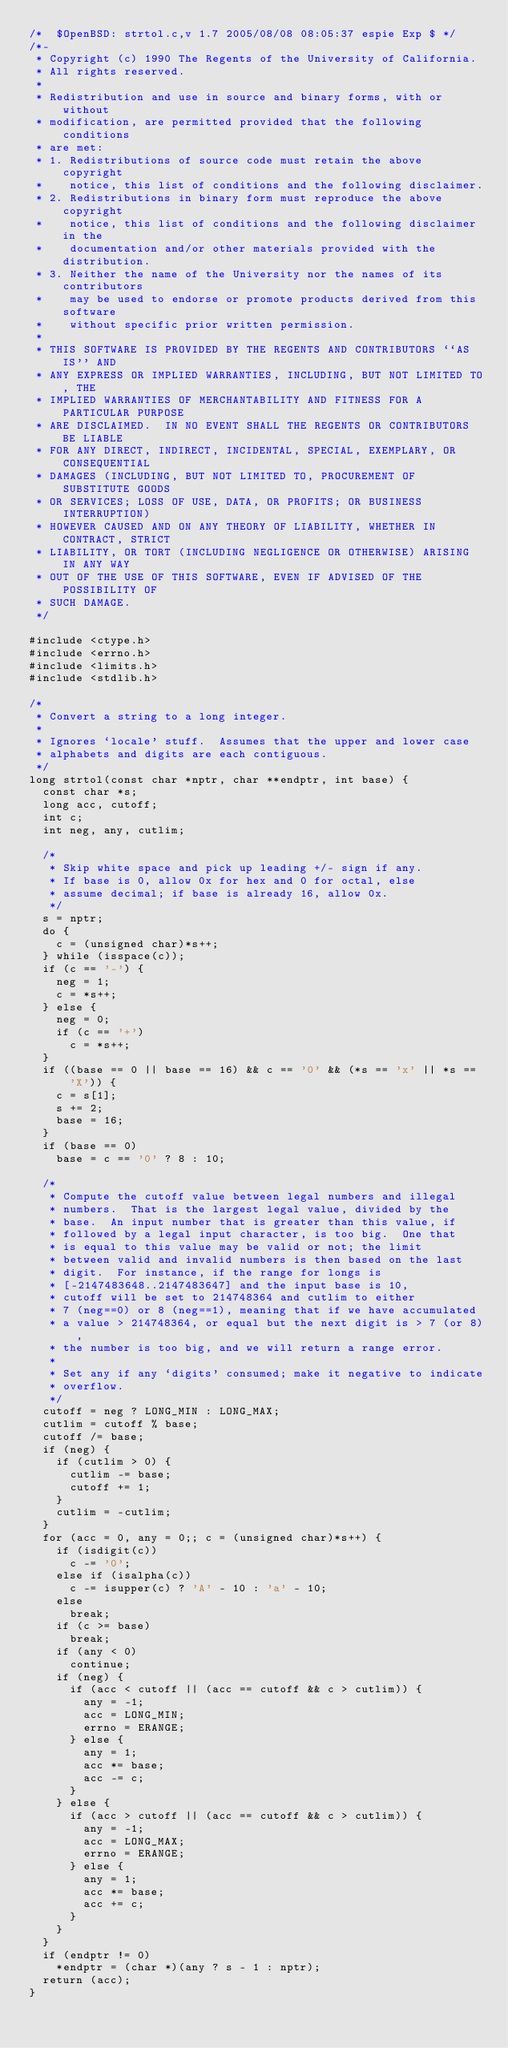Convert code to text. <code><loc_0><loc_0><loc_500><loc_500><_C_>/*  $OpenBSD: strtol.c,v 1.7 2005/08/08 08:05:37 espie Exp $ */
/*-
 * Copyright (c) 1990 The Regents of the University of California.
 * All rights reserved.
 *
 * Redistribution and use in source and binary forms, with or without
 * modification, are permitted provided that the following conditions
 * are met:
 * 1. Redistributions of source code must retain the above copyright
 *    notice, this list of conditions and the following disclaimer.
 * 2. Redistributions in binary form must reproduce the above copyright
 *    notice, this list of conditions and the following disclaimer in the
 *    documentation and/or other materials provided with the distribution.
 * 3. Neither the name of the University nor the names of its contributors
 *    may be used to endorse or promote products derived from this software
 *    without specific prior written permission.
 *
 * THIS SOFTWARE IS PROVIDED BY THE REGENTS AND CONTRIBUTORS ``AS IS'' AND
 * ANY EXPRESS OR IMPLIED WARRANTIES, INCLUDING, BUT NOT LIMITED TO, THE
 * IMPLIED WARRANTIES OF MERCHANTABILITY AND FITNESS FOR A PARTICULAR PURPOSE
 * ARE DISCLAIMED.  IN NO EVENT SHALL THE REGENTS OR CONTRIBUTORS BE LIABLE
 * FOR ANY DIRECT, INDIRECT, INCIDENTAL, SPECIAL, EXEMPLARY, OR CONSEQUENTIAL
 * DAMAGES (INCLUDING, BUT NOT LIMITED TO, PROCUREMENT OF SUBSTITUTE GOODS
 * OR SERVICES; LOSS OF USE, DATA, OR PROFITS; OR BUSINESS INTERRUPTION)
 * HOWEVER CAUSED AND ON ANY THEORY OF LIABILITY, WHETHER IN CONTRACT, STRICT
 * LIABILITY, OR TORT (INCLUDING NEGLIGENCE OR OTHERWISE) ARISING IN ANY WAY
 * OUT OF THE USE OF THIS SOFTWARE, EVEN IF ADVISED OF THE POSSIBILITY OF
 * SUCH DAMAGE.
 */

#include <ctype.h>
#include <errno.h>
#include <limits.h>
#include <stdlib.h>

/*
 * Convert a string to a long integer.
 *
 * Ignores `locale' stuff.  Assumes that the upper and lower case
 * alphabets and digits are each contiguous.
 */
long strtol(const char *nptr, char **endptr, int base) {
  const char *s;
  long acc, cutoff;
  int c;
  int neg, any, cutlim;

  /*
   * Skip white space and pick up leading +/- sign if any.
   * If base is 0, allow 0x for hex and 0 for octal, else
   * assume decimal; if base is already 16, allow 0x.
   */
  s = nptr;
  do {
    c = (unsigned char)*s++;
  } while (isspace(c));
  if (c == '-') {
    neg = 1;
    c = *s++;
  } else {
    neg = 0;
    if (c == '+')
      c = *s++;
  }
  if ((base == 0 || base == 16) && c == '0' && (*s == 'x' || *s == 'X')) {
    c = s[1];
    s += 2;
    base = 16;
  }
  if (base == 0)
    base = c == '0' ? 8 : 10;

  /*
   * Compute the cutoff value between legal numbers and illegal
   * numbers.  That is the largest legal value, divided by the
   * base.  An input number that is greater than this value, if
   * followed by a legal input character, is too big.  One that
   * is equal to this value may be valid or not; the limit
   * between valid and invalid numbers is then based on the last
   * digit.  For instance, if the range for longs is
   * [-2147483648..2147483647] and the input base is 10,
   * cutoff will be set to 214748364 and cutlim to either
   * 7 (neg==0) or 8 (neg==1), meaning that if we have accumulated
   * a value > 214748364, or equal but the next digit is > 7 (or 8),
   * the number is too big, and we will return a range error.
   *
   * Set any if any `digits' consumed; make it negative to indicate
   * overflow.
   */
  cutoff = neg ? LONG_MIN : LONG_MAX;
  cutlim = cutoff % base;
  cutoff /= base;
  if (neg) {
    if (cutlim > 0) {
      cutlim -= base;
      cutoff += 1;
    }
    cutlim = -cutlim;
  }
  for (acc = 0, any = 0;; c = (unsigned char)*s++) {
    if (isdigit(c))
      c -= '0';
    else if (isalpha(c))
      c -= isupper(c) ? 'A' - 10 : 'a' - 10;
    else
      break;
    if (c >= base)
      break;
    if (any < 0)
      continue;
    if (neg) {
      if (acc < cutoff || (acc == cutoff && c > cutlim)) {
        any = -1;
        acc = LONG_MIN;
        errno = ERANGE;
      } else {
        any = 1;
        acc *= base;
        acc -= c;
      }
    } else {
      if (acc > cutoff || (acc == cutoff && c > cutlim)) {
        any = -1;
        acc = LONG_MAX;
        errno = ERANGE;
      } else {
        any = 1;
        acc *= base;
        acc += c;
      }
    }
  }
  if (endptr != 0)
    *endptr = (char *)(any ? s - 1 : nptr);
  return (acc);
}
</code> 